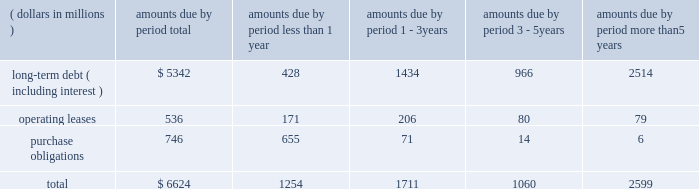It can issue debt securities , preferred stock , common stock , warrants , share purchase contracts or share purchase units without a predetermined limit .
Securities can be sold in one or more separate offerings with the size , price and terms to be determined at the time of sale .
Emerson 2019s financial structure provides the flexibility necessary to achieve its strategic objectives .
The company has been successful in efficiently deploying cash where needed worldwide to fund operations , complete acquisitions and sustain long-term growth .
At september 30 , 2017 , $ 3.1 billion of the company 2019s cash was held outside the u.s .
( primarily in europe and asia ) , $ 1.4 billion of which income taxes have been provided for , and was generally available for repatriation to the u.s .
Under current tax law , repatriated cash may be subject to u.s .
Federal income taxes , net of available foreign tax credits .
The company routinely repatriates a portion of its non-u.s .
Cash from earnings each year , or otherwise when it can be accomplished tax efficiently , and provides for u.s .
Income taxes as appropriate .
The company has been able to readily meet all its funding requirements and currently believes that sufficient funds will be available to meet the company 2019s needs in the foreseeable future through operating cash flow , existing resources , short- and long-term debt capacity or backup credit lines .
Contractual obligations at september 30 , 2017 , the company 2019s contractual obligations , including estimated payments , are as follows : amounts due by period less more than 1 2013 3 3 2013 5 than ( dollars in millions ) total 1 year years years 5 years long-term debt ( including interest ) $ 5342 428 1434 966 2514 .
Purchase obligations consist primarily of inventory purchases made in the normal course of business to meet operational requirements .
The table above does not include $ 2.0 billion of other noncurrent liabilities recorded in the balance sheet and summarized in note 19 , which consist primarily of pension and postretirement plan liabilities , deferred income taxes and unrecognized tax benefits , because it is not certain when these amounts will become due .
See notes 11 and 12 for estimated future benefit payments and note 14 for additional information on deferred income taxes .
Financial instruments the company is exposed to market risk related to changes in interest rates , foreign currency exchange rates and commodity prices , and selectively uses derivative financial instruments , including forwards , swaps and purchased options to manage these risks .
The company does not hold derivatives for trading or speculative purposes .
The value of derivatives and other financial instruments is subject to change as a result of market movements in rates and prices .
Sensitivity analysis is one technique used to forecast the impact of these movements .
Based on a hypothetical 10 percent increase in interest rates , a 10 percent decrease in commodity prices or a 10 percent weakening in the u.s .
Dollar across all currencies , the potential losses in future earnings , fair value or cash flows are not material .
Sensitivity analysis has limitations ; for example , a weaker u.s .
Dollar would benefit future earnings through favorable translation of non-u.s .
Operating results , and lower commodity prices would benefit future earnings through lower cost of sales .
See notes 1 , and 8 through 10 .
Critical accounting policies preparation of the company 2019s financial statements requires management to make judgments , assumptions and estimates regarding uncertainties that could affect reported revenue , expenses , assets , liabilities and equity .
Note 1 describes the significant accounting policies used in preparation of the consolidated financial statements .
The most significant areas where management judgments and estimates impact the primary financial statements are described below .
Actual results in these areas could differ materially from management 2019s estimates under different assumptions or conditions .
Revenue recognition the company recognizes a large majority of its revenue through the sale of manufactured products and records the sale when products are shipped or delivered , title and risk of loss pass to the customer , and collection is reasonably assured .
In certain circumstances , revenue is recognized using the percentage-of- completion method , as performance occurs , or in accordance with asc 985-605 related to software .
Sales arrangements sometimes involve delivering multiple elements , which requires management judgment that affects the amount and timing of revenue recognized .
In these instances , the revenue assigned to each element is based on vendor-specific objective evidence , third-party evidence or a management estimate of the relative selling price .
Revenue is recognized for delivered elements if they have value to the customer on a stand-alone basis and performance related to the undelivered items is probable and substantially in the company 2019s control , or the undelivered elements are inconsequential or perfunctory and there are no unsatisfied contingencies related to payment .
The vast majority of deliverables are tangible products , with a smaller portion attributable to installation , service or maintenance .
Management believes that all relevant criteria and conditions are considered when recognizing revenue. .
What percent of total contractual obligations is due to long-term debt ( including interest ) ? 
Computations: (5342 / 6624)
Answer: 0.80646. It can issue debt securities , preferred stock , common stock , warrants , share purchase contracts or share purchase units without a predetermined limit .
Securities can be sold in one or more separate offerings with the size , price and terms to be determined at the time of sale .
Emerson 2019s financial structure provides the flexibility necessary to achieve its strategic objectives .
The company has been successful in efficiently deploying cash where needed worldwide to fund operations , complete acquisitions and sustain long-term growth .
At september 30 , 2017 , $ 3.1 billion of the company 2019s cash was held outside the u.s .
( primarily in europe and asia ) , $ 1.4 billion of which income taxes have been provided for , and was generally available for repatriation to the u.s .
Under current tax law , repatriated cash may be subject to u.s .
Federal income taxes , net of available foreign tax credits .
The company routinely repatriates a portion of its non-u.s .
Cash from earnings each year , or otherwise when it can be accomplished tax efficiently , and provides for u.s .
Income taxes as appropriate .
The company has been able to readily meet all its funding requirements and currently believes that sufficient funds will be available to meet the company 2019s needs in the foreseeable future through operating cash flow , existing resources , short- and long-term debt capacity or backup credit lines .
Contractual obligations at september 30 , 2017 , the company 2019s contractual obligations , including estimated payments , are as follows : amounts due by period less more than 1 2013 3 3 2013 5 than ( dollars in millions ) total 1 year years years 5 years long-term debt ( including interest ) $ 5342 428 1434 966 2514 .
Purchase obligations consist primarily of inventory purchases made in the normal course of business to meet operational requirements .
The table above does not include $ 2.0 billion of other noncurrent liabilities recorded in the balance sheet and summarized in note 19 , which consist primarily of pension and postretirement plan liabilities , deferred income taxes and unrecognized tax benefits , because it is not certain when these amounts will become due .
See notes 11 and 12 for estimated future benefit payments and note 14 for additional information on deferred income taxes .
Financial instruments the company is exposed to market risk related to changes in interest rates , foreign currency exchange rates and commodity prices , and selectively uses derivative financial instruments , including forwards , swaps and purchased options to manage these risks .
The company does not hold derivatives for trading or speculative purposes .
The value of derivatives and other financial instruments is subject to change as a result of market movements in rates and prices .
Sensitivity analysis is one technique used to forecast the impact of these movements .
Based on a hypothetical 10 percent increase in interest rates , a 10 percent decrease in commodity prices or a 10 percent weakening in the u.s .
Dollar across all currencies , the potential losses in future earnings , fair value or cash flows are not material .
Sensitivity analysis has limitations ; for example , a weaker u.s .
Dollar would benefit future earnings through favorable translation of non-u.s .
Operating results , and lower commodity prices would benefit future earnings through lower cost of sales .
See notes 1 , and 8 through 10 .
Critical accounting policies preparation of the company 2019s financial statements requires management to make judgments , assumptions and estimates regarding uncertainties that could affect reported revenue , expenses , assets , liabilities and equity .
Note 1 describes the significant accounting policies used in preparation of the consolidated financial statements .
The most significant areas where management judgments and estimates impact the primary financial statements are described below .
Actual results in these areas could differ materially from management 2019s estimates under different assumptions or conditions .
Revenue recognition the company recognizes a large majority of its revenue through the sale of manufactured products and records the sale when products are shipped or delivered , title and risk of loss pass to the customer , and collection is reasonably assured .
In certain circumstances , revenue is recognized using the percentage-of- completion method , as performance occurs , or in accordance with asc 985-605 related to software .
Sales arrangements sometimes involve delivering multiple elements , which requires management judgment that affects the amount and timing of revenue recognized .
In these instances , the revenue assigned to each element is based on vendor-specific objective evidence , third-party evidence or a management estimate of the relative selling price .
Revenue is recognized for delivered elements if they have value to the customer on a stand-alone basis and performance related to the undelivered items is probable and substantially in the company 2019s control , or the undelivered elements are inconsequential or perfunctory and there are no unsatisfied contingencies related to payment .
The vast majority of deliverables are tangible products , with a smaller portion attributable to installation , service or maintenance .
Management believes that all relevant criteria and conditions are considered when recognizing revenue. .
What percent of total contractual obligations is due to purchase obligations? 
Computations: (746 / 6624)
Answer: 0.11262. 